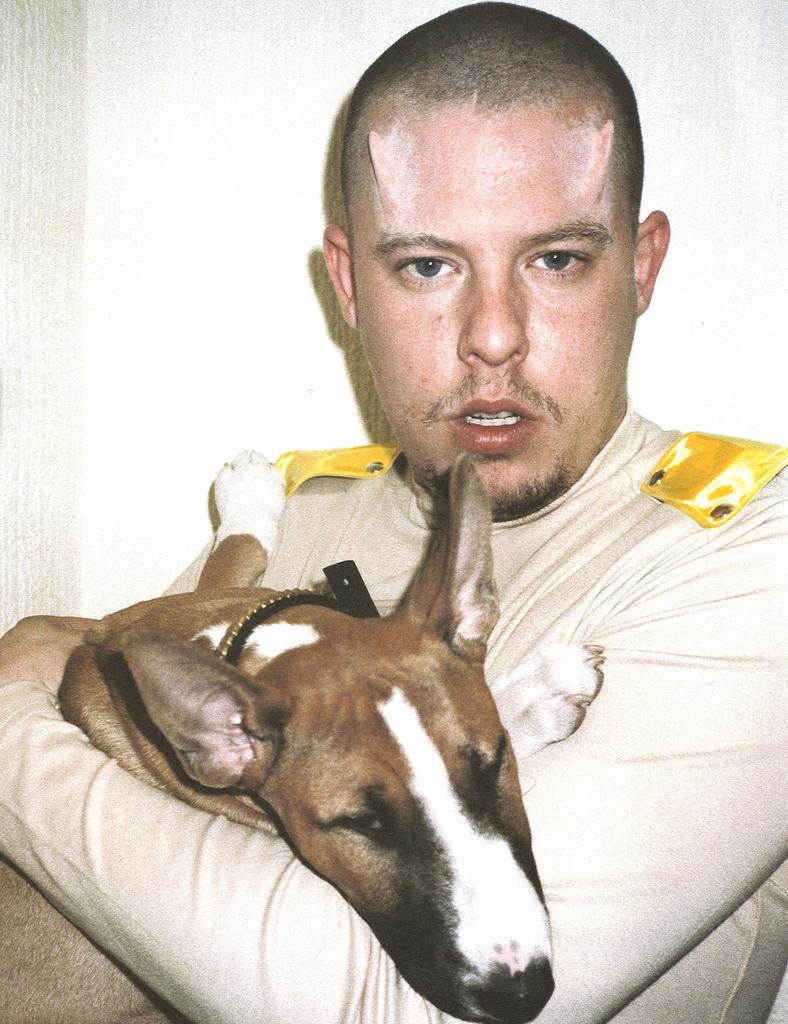Can you describe this image briefly? In this picture there is a person who is standing at the center of the image by holding a dog in his hands and there are horns on the forehead of the person. 